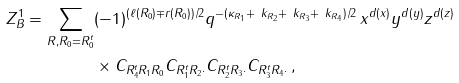<formula> <loc_0><loc_0><loc_500><loc_500>Z ^ { 1 } _ { B } = \sum _ { R , R _ { 0 } = R _ { 0 } ^ { t } } & ( - 1 ) ^ { ( \ell ( R _ { 0 } ) \mp r ( R _ { 0 } ) ) / 2 } q ^ { - ( \kappa _ { R _ { 1 } } + \ k _ { R _ { 2 } } + \ k _ { R _ { 3 } } + \ k _ { R _ { 4 } } ) / 2 } \, x ^ { d ( x ) } y ^ { d ( y ) } z ^ { d ( z ) } \\ & \times C _ { R _ { 4 } ^ { t } R _ { 1 } R _ { 0 } } C _ { R _ { 1 } ^ { t } R _ { 2 } \cdot } C _ { R _ { 2 } ^ { t } R _ { 3 } \cdot } C _ { R _ { 3 } ^ { t } R _ { 4 } \cdot } \, ,</formula> 